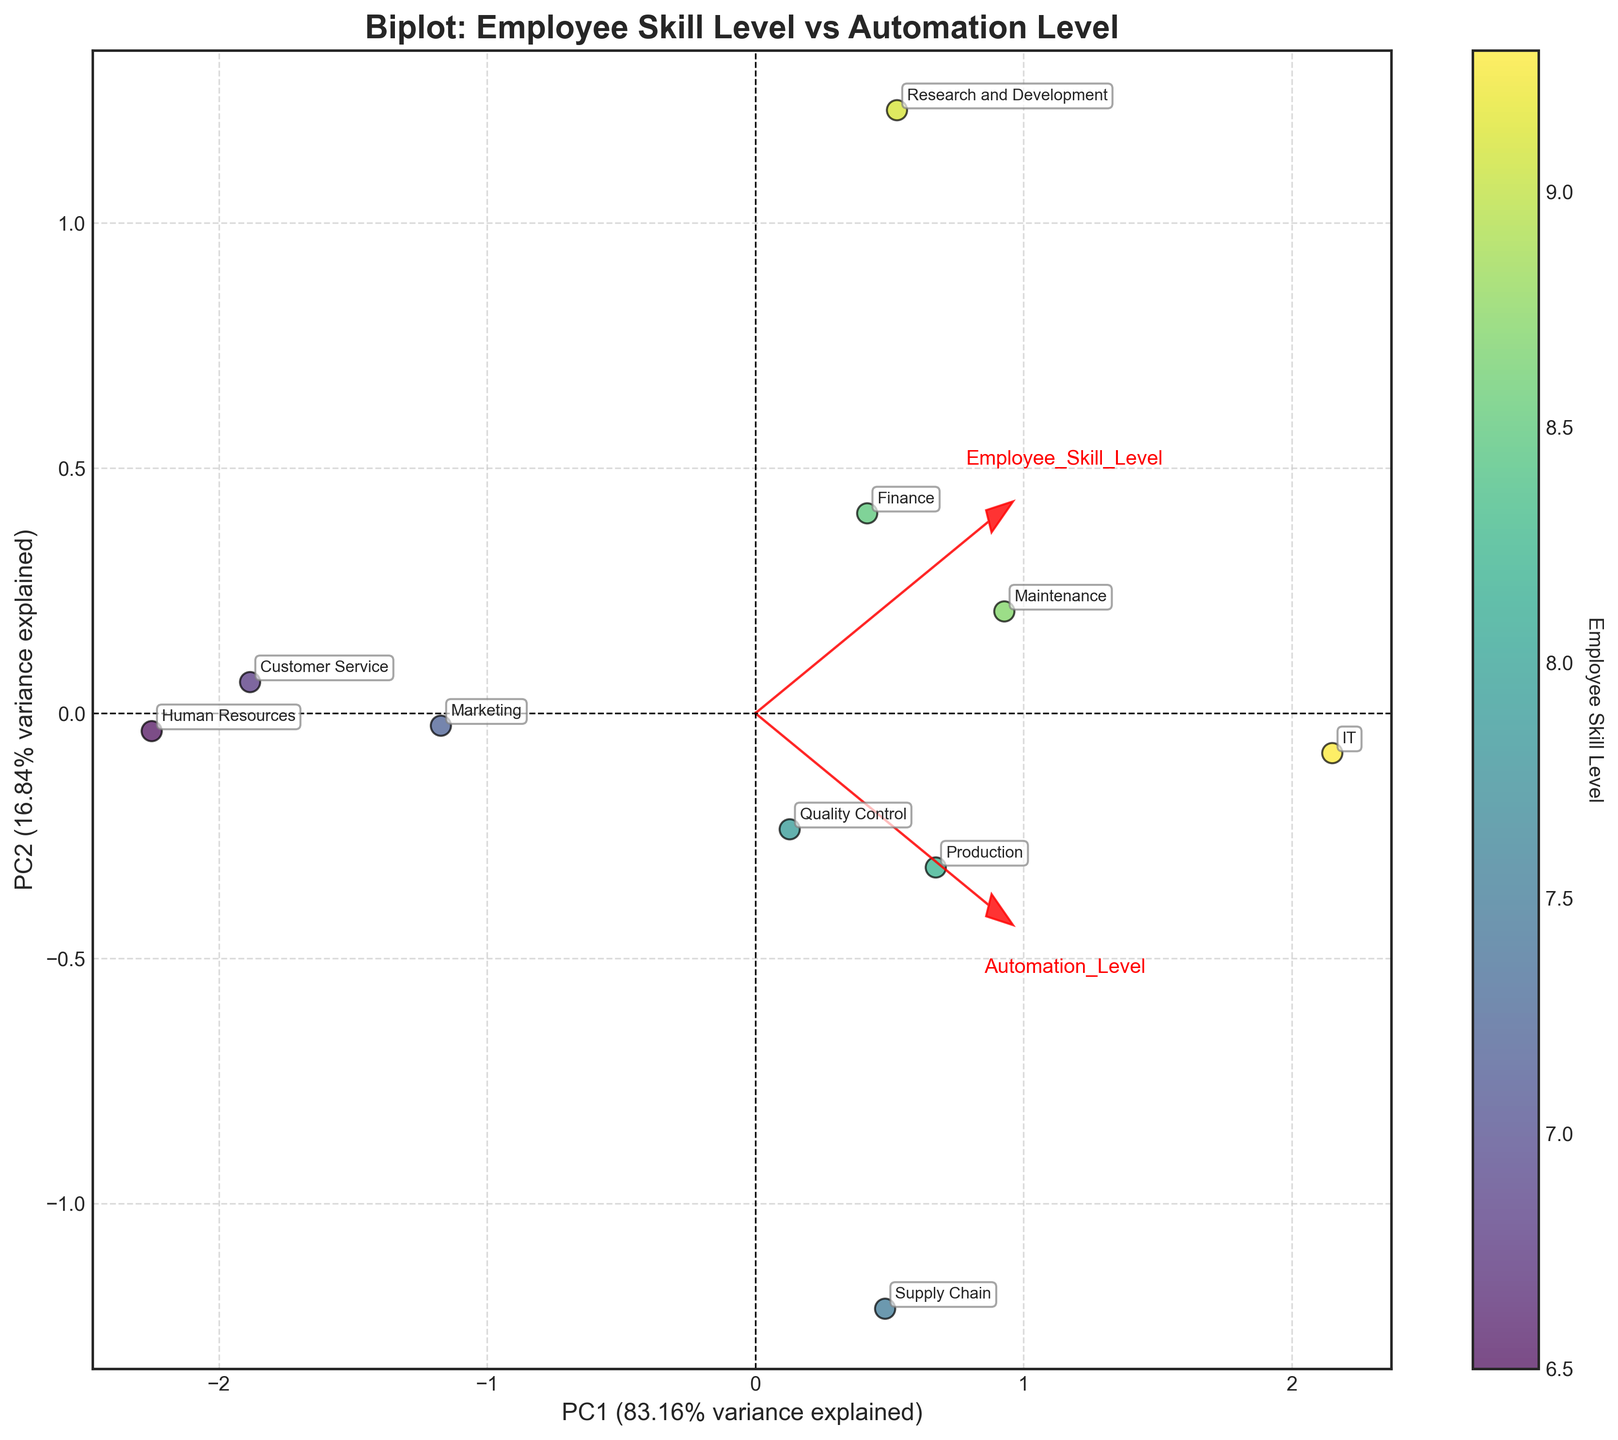How many departments are shown in the plot? Count the number of unique department annotations visible in the plot. Each department has its label, and there are 10 labeled points.
Answer: 10 What is the title of the plot? The title of the plot is typically located at the top, and in this case, it reads "Biplot: Employee Skill Level vs Automation Level".
Answer: Biplot: Employee Skill Level vs Automation Level Which department has the highest employee skill level? Identify the department with the highest employee skill level by looking at the color gradient linked to the color bar. The IT department exhibits the highest skill level with a prominently higher position in the gradient.
Answer: IT What percentage of variance is explained by PC1? Look at the xlabel of the plot which states the percentage of variance explained by the first principal component (PC1). It is stated as a percentage near the x-axis label.
Answer: ~59% Is there a department where the employee skill level and automation level are both lower compared to the IT department? If so, name one. Compare the scatter points and color gradients. The Customer Service department is noted to have both lower employee skill and automation levels as displayed by its position on the plot.
Answer: Customer Service Which loading vector (red arrow) indicates the direction of increasing employee skill level? Examine the plot for the red arrows and their labels. The arrow labeled "Employee_Skill_Level" shows the direction of increasing skill level.
Answer: The arrow labeled "Employee_Skill_Level" Which department has the closest balance between employee skill level and automation level? Identify the department positioned closest to the 45-degree line from the origin, indicative of a balance. Maintenance and Supply Chain are closely balanced; Maintenance is marginally closer.
Answer: Maintenance How are the departments of Production and Finance positioned relative to each other on the plot? Locate both departments on the plot. Production (8.2,7.5) and Finance (8.5,6.4) show that Production is slightly lower on the y-axis and Finance higher on the x-axis.
Answer: Production is slightly lower on automation, higher on skill What does the second principal component (PC2) capture more: Employee Skill Level or Automation Level? Look at the loading vectors' projections on PC2. The vector line for 'Automation_Level' aligns more prominently with PC2 compared to 'Employee_Skill_Level'.
Answer: Automation Level 